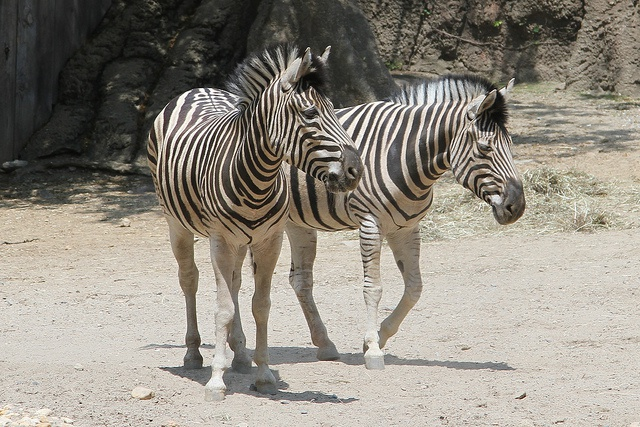Describe the objects in this image and their specific colors. I can see zebra in black, gray, lightgray, and darkgray tones and zebra in black, gray, lightgray, and darkgray tones in this image. 